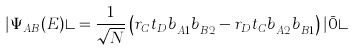<formula> <loc_0><loc_0><loc_500><loc_500>| \Psi _ { A B } ( E ) \rangle = \frac { 1 } { \sqrt { N } } \left ( r _ { C } t _ { D } b _ { A 1 } ^ { \dagger } b _ { B 2 } ^ { \dagger } - r _ { D } t _ { C } b _ { A 2 } ^ { \dagger } b _ { B 1 } ^ { \dagger } \right ) | \bar { 0 } \rangle</formula> 